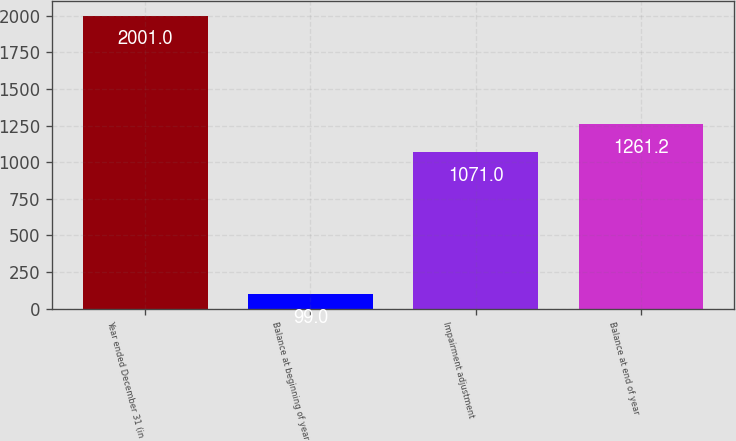<chart> <loc_0><loc_0><loc_500><loc_500><bar_chart><fcel>Year ended December 31 (in<fcel>Balance at beginning of year<fcel>Impairment adjustment<fcel>Balance at end of year<nl><fcel>2001<fcel>99<fcel>1071<fcel>1261.2<nl></chart> 